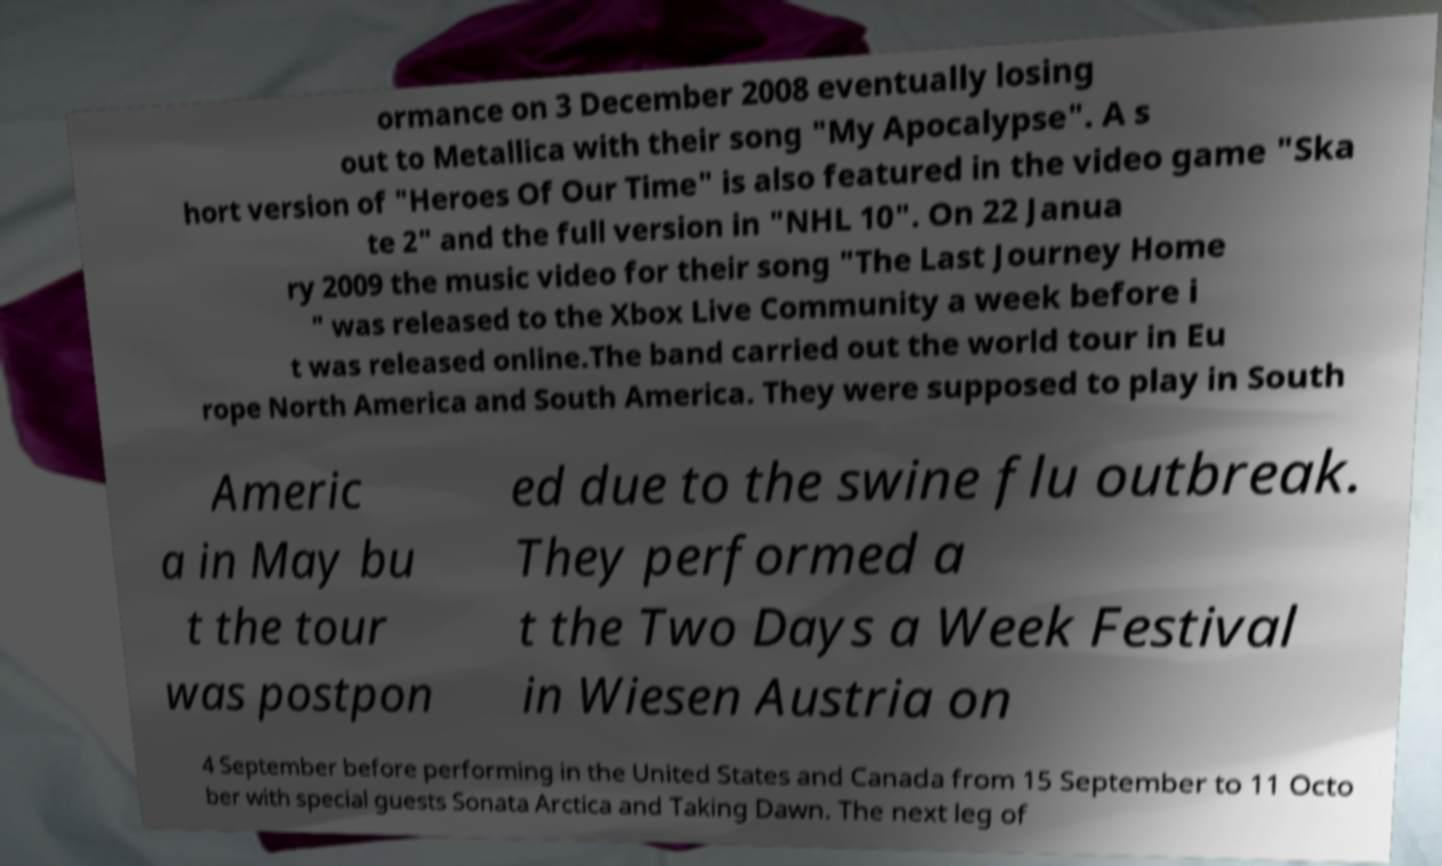Can you read and provide the text displayed in the image?This photo seems to have some interesting text. Can you extract and type it out for me? ormance on 3 December 2008 eventually losing out to Metallica with their song "My Apocalypse". A s hort version of "Heroes Of Our Time" is also featured in the video game "Ska te 2" and the full version in "NHL 10". On 22 Janua ry 2009 the music video for their song "The Last Journey Home " was released to the Xbox Live Community a week before i t was released online.The band carried out the world tour in Eu rope North America and South America. They were supposed to play in South Americ a in May bu t the tour was postpon ed due to the swine flu outbreak. They performed a t the Two Days a Week Festival in Wiesen Austria on 4 September before performing in the United States and Canada from 15 September to 11 Octo ber with special guests Sonata Arctica and Taking Dawn. The next leg of 